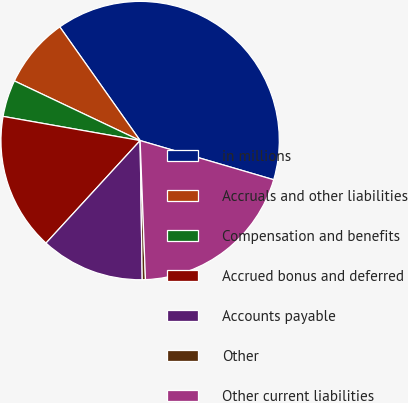<chart> <loc_0><loc_0><loc_500><loc_500><pie_chart><fcel>in millions<fcel>Accruals and other liabilities<fcel>Compensation and benefits<fcel>Accrued bonus and deferred<fcel>Accounts payable<fcel>Other<fcel>Other current liabilities<nl><fcel>39.33%<fcel>8.16%<fcel>4.27%<fcel>15.96%<fcel>12.06%<fcel>0.37%<fcel>19.85%<nl></chart> 